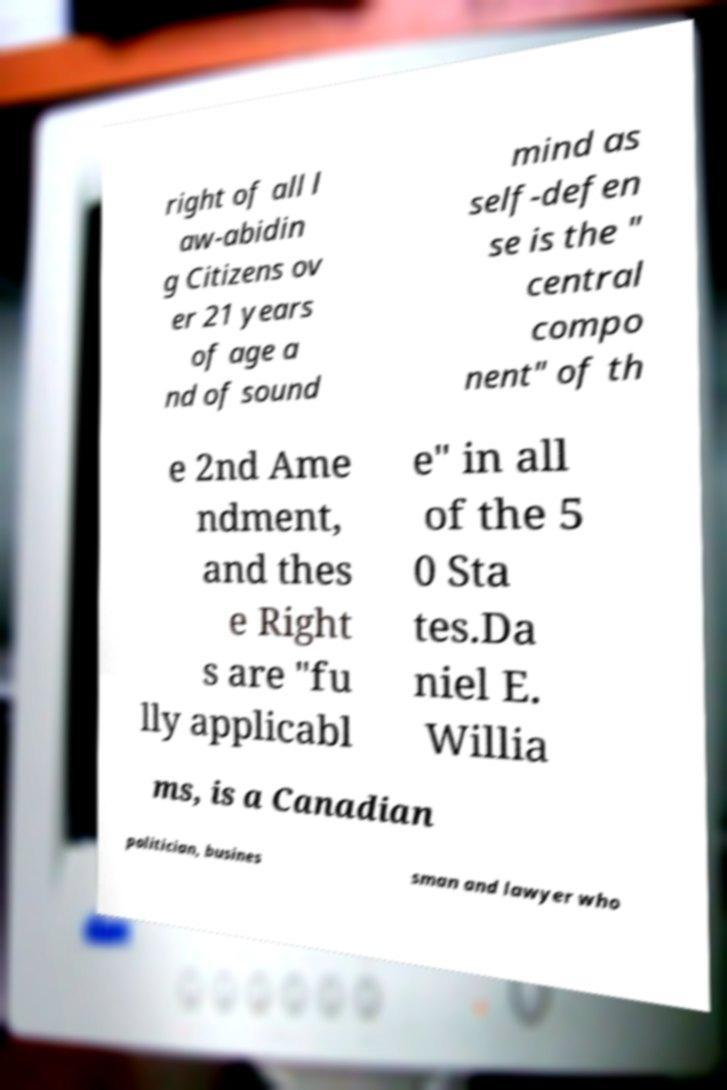For documentation purposes, I need the text within this image transcribed. Could you provide that? right of all l aw-abidin g Citizens ov er 21 years of age a nd of sound mind as self-defen se is the " central compo nent" of th e 2nd Ame ndment, and thes e Right s are "fu lly applicabl e" in all of the 5 0 Sta tes.Da niel E. Willia ms, is a Canadian politician, busines sman and lawyer who 